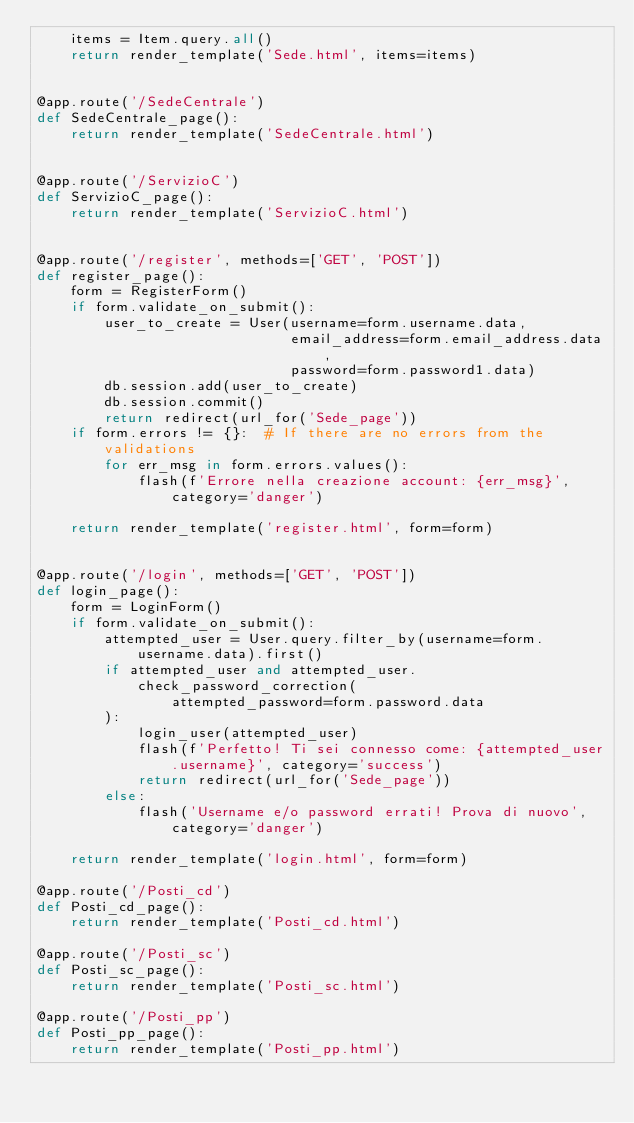<code> <loc_0><loc_0><loc_500><loc_500><_Python_>    items = Item.query.all()
    return render_template('Sede.html', items=items)


@app.route('/SedeCentrale')
def SedeCentrale_page():
    return render_template('SedeCentrale.html')


@app.route('/ServizioC')
def ServizioC_page():
    return render_template('ServizioC.html')


@app.route('/register', methods=['GET', 'POST'])
def register_page():
    form = RegisterForm()
    if form.validate_on_submit():
        user_to_create = User(username=form.username.data,
                              email_address=form.email_address.data,
                              password=form.password1.data)
        db.session.add(user_to_create)
        db.session.commit()
        return redirect(url_for('Sede_page'))
    if form.errors != {}:  # If there are no errors from the validations
        for err_msg in form.errors.values():
            flash(f'Errore nella creazione account: {err_msg}', category='danger')

    return render_template('register.html', form=form)


@app.route('/login', methods=['GET', 'POST'])
def login_page():
    form = LoginForm()
    if form.validate_on_submit():
        attempted_user = User.query.filter_by(username=form.username.data).first()
        if attempted_user and attempted_user.check_password_correction(
                attempted_password=form.password.data
        ):
            login_user(attempted_user)
            flash(f'Perfetto! Ti sei connesso come: {attempted_user.username}', category='success')
            return redirect(url_for('Sede_page'))
        else:
            flash('Username e/o password errati! Prova di nuovo', category='danger')

    return render_template('login.html', form=form)

@app.route('/Posti_cd')
def Posti_cd_page():
    return render_template('Posti_cd.html')

@app.route('/Posti_sc')
def Posti_sc_page():
    return render_template('Posti_sc.html')

@app.route('/Posti_pp')
def Posti_pp_page():
    return render_template('Posti_pp.html')</code> 